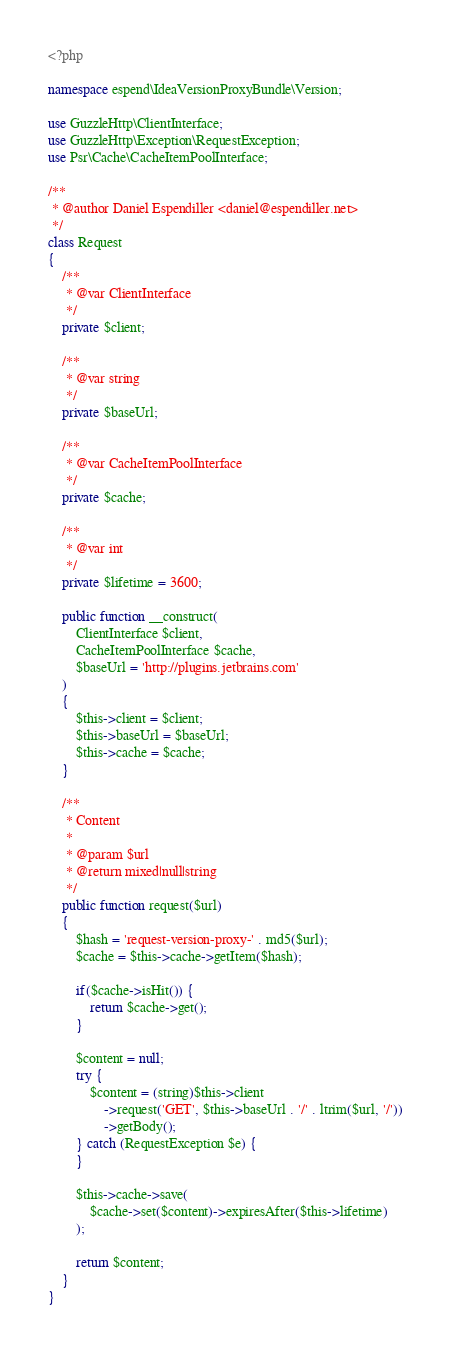Convert code to text. <code><loc_0><loc_0><loc_500><loc_500><_PHP_><?php

namespace espend\IdeaVersionProxyBundle\Version;

use GuzzleHttp\ClientInterface;
use GuzzleHttp\Exception\RequestException;
use Psr\Cache\CacheItemPoolInterface;

/**
 * @author Daniel Espendiller <daniel@espendiller.net>
 */
class Request
{
    /**
     * @var ClientInterface
     */
    private $client;

    /**
     * @var string
     */
    private $baseUrl;

    /**
     * @var CacheItemPoolInterface
     */
    private $cache;

    /**
     * @var int
     */
    private $lifetime = 3600;

    public function __construct(
        ClientInterface $client,
        CacheItemPoolInterface $cache,
        $baseUrl = 'http://plugins.jetbrains.com'
    )
    {
        $this->client = $client;
        $this->baseUrl = $baseUrl;
        $this->cache = $cache;
    }

    /**
     * Content
     *
     * @param $url
     * @return mixed|null|string
     */
    public function request($url)
    {
        $hash = 'request-version-proxy-' . md5($url);
        $cache = $this->cache->getItem($hash);

        if($cache->isHit()) {
            return $cache->get();
        }

        $content = null;
        try {
            $content = (string)$this->client
                ->request('GET', $this->baseUrl . '/' . ltrim($url, '/'))
                ->getBody();
        } catch (RequestException $e) {
        }

        $this->cache->save(
            $cache->set($content)->expiresAfter($this->lifetime)
        );
        
        return $content;
    }
}</code> 